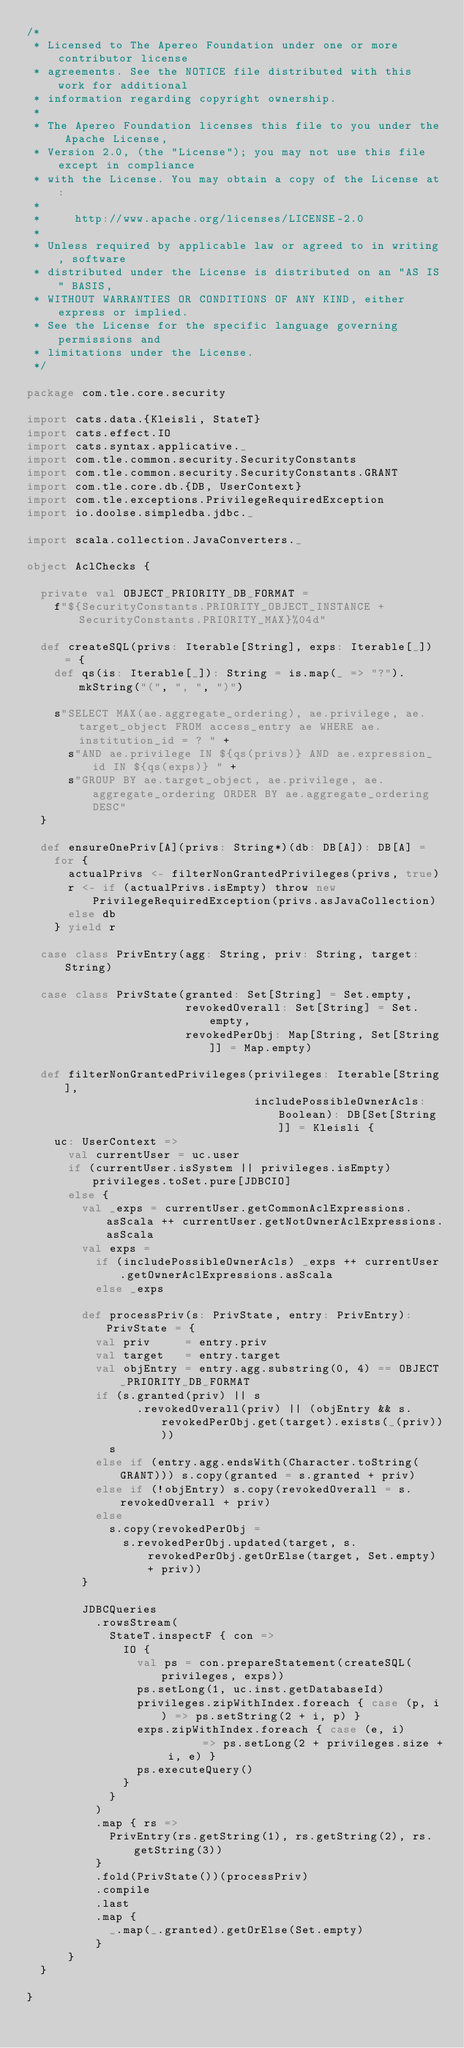Convert code to text. <code><loc_0><loc_0><loc_500><loc_500><_Scala_>/*
 * Licensed to The Apereo Foundation under one or more contributor license
 * agreements. See the NOTICE file distributed with this work for additional
 * information regarding copyright ownership.
 *
 * The Apereo Foundation licenses this file to you under the Apache License,
 * Version 2.0, (the "License"); you may not use this file except in compliance
 * with the License. You may obtain a copy of the License at:
 *
 *     http://www.apache.org/licenses/LICENSE-2.0
 *
 * Unless required by applicable law or agreed to in writing, software
 * distributed under the License is distributed on an "AS IS" BASIS,
 * WITHOUT WARRANTIES OR CONDITIONS OF ANY KIND, either express or implied.
 * See the License for the specific language governing permissions and
 * limitations under the License.
 */

package com.tle.core.security

import cats.data.{Kleisli, StateT}
import cats.effect.IO
import cats.syntax.applicative._
import com.tle.common.security.SecurityConstants
import com.tle.common.security.SecurityConstants.GRANT
import com.tle.core.db.{DB, UserContext}
import com.tle.exceptions.PrivilegeRequiredException
import io.doolse.simpledba.jdbc._

import scala.collection.JavaConverters._

object AclChecks {

  private val OBJECT_PRIORITY_DB_FORMAT =
    f"${SecurityConstants.PRIORITY_OBJECT_INSTANCE + SecurityConstants.PRIORITY_MAX}%04d"

  def createSQL(privs: Iterable[String], exps: Iterable[_]) = {
    def qs(is: Iterable[_]): String = is.map(_ => "?").mkString("(", ", ", ")")

    s"SELECT MAX(ae.aggregate_ordering), ae.privilege, ae.target_object FROM access_entry ae WHERE ae.institution_id = ? " +
      s"AND ae.privilege IN ${qs(privs)} AND ae.expression_id IN ${qs(exps)} " +
      s"GROUP BY ae.target_object, ae.privilege, ae.aggregate_ordering ORDER BY ae.aggregate_ordering DESC"
  }

  def ensureOnePriv[A](privs: String*)(db: DB[A]): DB[A] =
    for {
      actualPrivs <- filterNonGrantedPrivileges(privs, true)
      r <- if (actualPrivs.isEmpty) throw new PrivilegeRequiredException(privs.asJavaCollection)
      else db
    } yield r

  case class PrivEntry(agg: String, priv: String, target: String)

  case class PrivState(granted: Set[String] = Set.empty,
                       revokedOverall: Set[String] = Set.empty,
                       revokedPerObj: Map[String, Set[String]] = Map.empty)

  def filterNonGrantedPrivileges(privileges: Iterable[String],
                                 includePossibleOwnerAcls: Boolean): DB[Set[String]] = Kleisli {
    uc: UserContext =>
      val currentUser = uc.user
      if (currentUser.isSystem || privileges.isEmpty) privileges.toSet.pure[JDBCIO]
      else {
        val _exps = currentUser.getCommonAclExpressions.asScala ++ currentUser.getNotOwnerAclExpressions.asScala
        val exps =
          if (includePossibleOwnerAcls) _exps ++ currentUser.getOwnerAclExpressions.asScala
          else _exps

        def processPriv(s: PrivState, entry: PrivEntry): PrivState = {
          val priv     = entry.priv
          val target   = entry.target
          val objEntry = entry.agg.substring(0, 4) == OBJECT_PRIORITY_DB_FORMAT
          if (s.granted(priv) || s
                .revokedOverall(priv) || (objEntry && s.revokedPerObj.get(target).exists(_(priv))))
            s
          else if (entry.agg.endsWith(Character.toString(GRANT))) s.copy(granted = s.granted + priv)
          else if (!objEntry) s.copy(revokedOverall = s.revokedOverall + priv)
          else
            s.copy(revokedPerObj =
              s.revokedPerObj.updated(target, s.revokedPerObj.getOrElse(target, Set.empty) + priv))
        }

        JDBCQueries
          .rowsStream(
            StateT.inspectF { con =>
              IO {
                val ps = con.prepareStatement(createSQL(privileges, exps))
                ps.setLong(1, uc.inst.getDatabaseId)
                privileges.zipWithIndex.foreach { case (p, i) => ps.setString(2 + i, p) }
                exps.zipWithIndex.foreach { case (e, i)       => ps.setLong(2 + privileges.size + i, e) }
                ps.executeQuery()
              }
            }
          )
          .map { rs =>
            PrivEntry(rs.getString(1), rs.getString(2), rs.getString(3))
          }
          .fold(PrivState())(processPriv)
          .compile
          .last
          .map {
            _.map(_.granted).getOrElse(Set.empty)
          }
      }
  }

}
</code> 